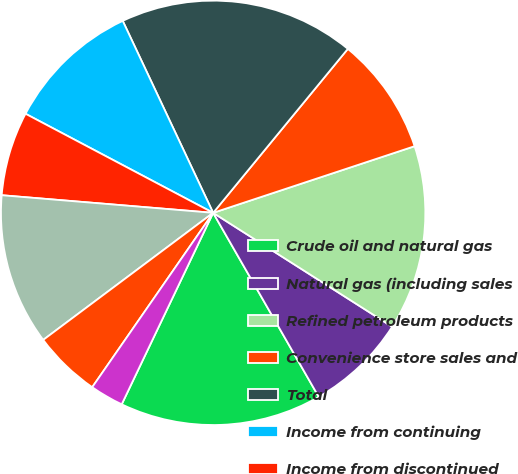<chart> <loc_0><loc_0><loc_500><loc_500><pie_chart><fcel>Crude oil and natural gas<fcel>Natural gas (including sales<fcel>Refined petroleum products<fcel>Convenience store sales and<fcel>Total<fcel>Income from continuing<fcel>Income from discontinued<fcel>Net income<fcel>Less Net income (loss)<fcel>Continuing operations<nl><fcel>15.38%<fcel>7.69%<fcel>14.1%<fcel>8.97%<fcel>17.95%<fcel>10.26%<fcel>6.41%<fcel>11.54%<fcel>5.13%<fcel>2.56%<nl></chart> 